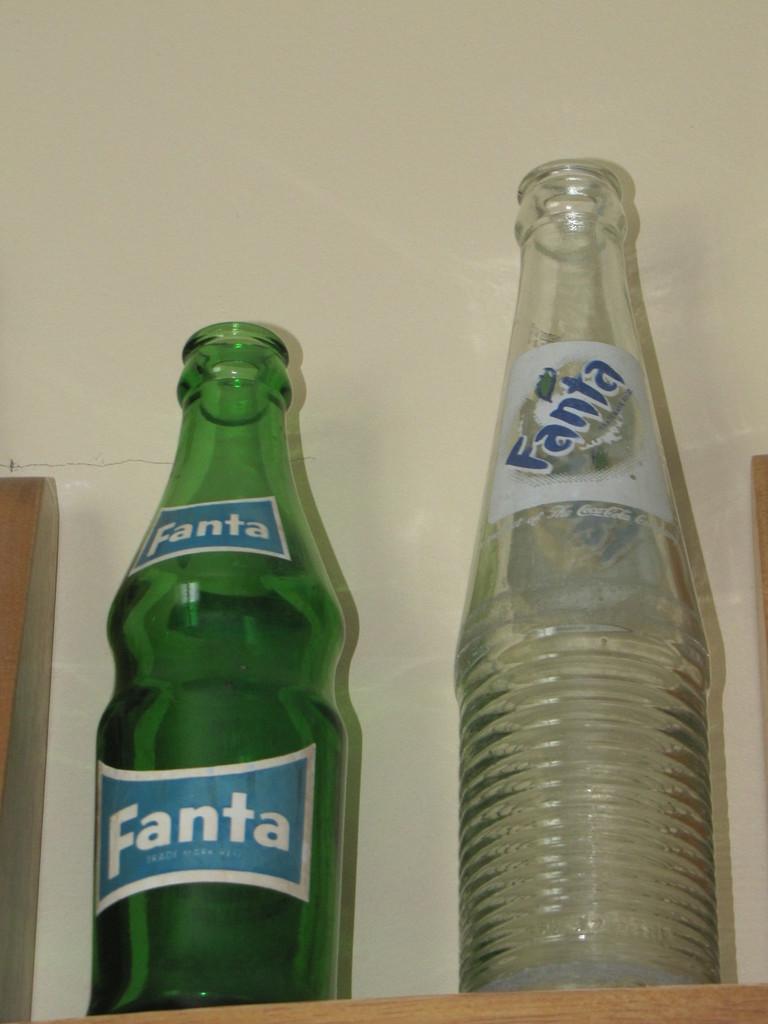Is the green bottle the same soda as the other one?
Provide a short and direct response. Yes. What is the brand of these bottles?
Make the answer very short. Fanta. 